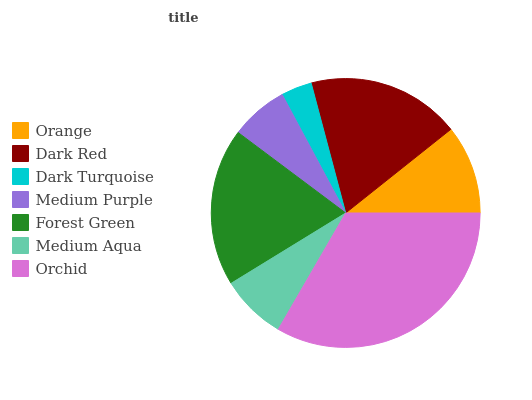Is Dark Turquoise the minimum?
Answer yes or no. Yes. Is Orchid the maximum?
Answer yes or no. Yes. Is Dark Red the minimum?
Answer yes or no. No. Is Dark Red the maximum?
Answer yes or no. No. Is Dark Red greater than Orange?
Answer yes or no. Yes. Is Orange less than Dark Red?
Answer yes or no. Yes. Is Orange greater than Dark Red?
Answer yes or no. No. Is Dark Red less than Orange?
Answer yes or no. No. Is Orange the high median?
Answer yes or no. Yes. Is Orange the low median?
Answer yes or no. Yes. Is Medium Purple the high median?
Answer yes or no. No. Is Dark Turquoise the low median?
Answer yes or no. No. 